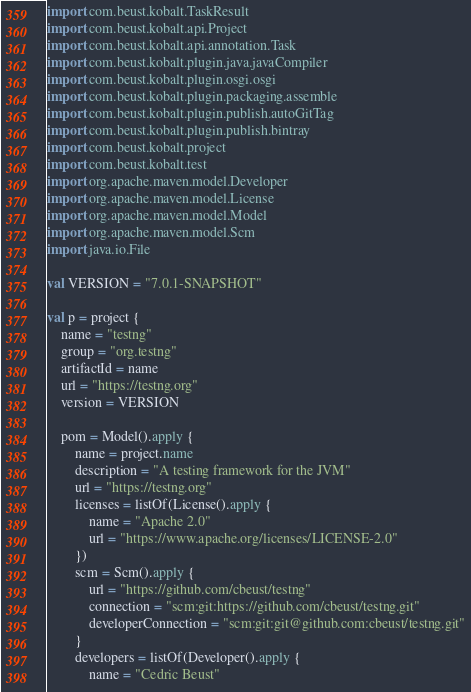<code> <loc_0><loc_0><loc_500><loc_500><_Kotlin_>
import com.beust.kobalt.TaskResult
import com.beust.kobalt.api.Project
import com.beust.kobalt.api.annotation.Task
import com.beust.kobalt.plugin.java.javaCompiler
import com.beust.kobalt.plugin.osgi.osgi
import com.beust.kobalt.plugin.packaging.assemble
import com.beust.kobalt.plugin.publish.autoGitTag
import com.beust.kobalt.plugin.publish.bintray
import com.beust.kobalt.project
import com.beust.kobalt.test
import org.apache.maven.model.Developer
import org.apache.maven.model.License
import org.apache.maven.model.Model
import org.apache.maven.model.Scm
import java.io.File

val VERSION = "7.0.1-SNAPSHOT"

val p = project {
    name = "testng"
    group = "org.testng"
    artifactId = name
    url = "https://testng.org"
    version = VERSION

    pom = Model().apply {
        name = project.name
        description = "A testing framework for the JVM"
        url = "https://testng.org"
        licenses = listOf(License().apply {
            name = "Apache 2.0"
            url = "https://www.apache.org/licenses/LICENSE-2.0"
        })
        scm = Scm().apply {
            url = "https://github.com/cbeust/testng"
            connection = "scm:git:https://github.com/cbeust/testng.git"
            developerConnection = "scm:git:git@github.com:cbeust/testng.git"
        }
        developers = listOf(Developer().apply {
            name = "Cedric Beust"</code> 